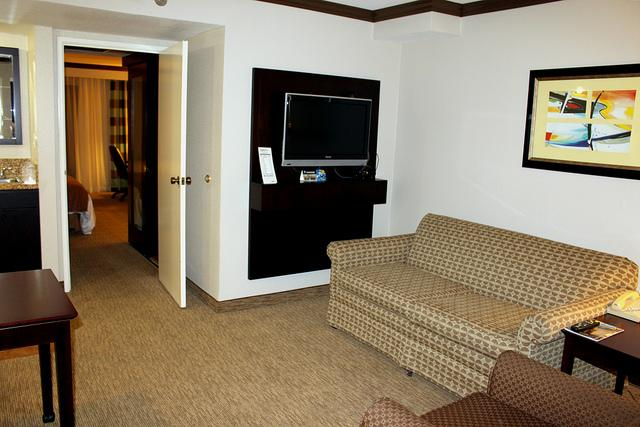Which country is famous for paintings? italy 